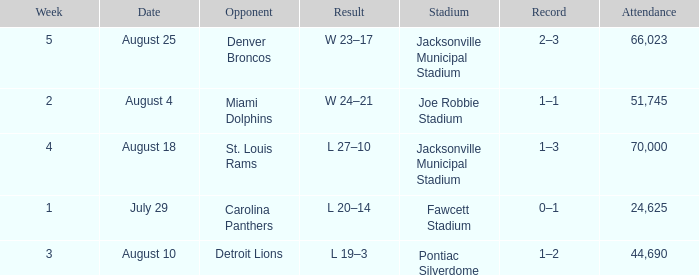WHEN has a Opponent of miami dolphins? August 4. 